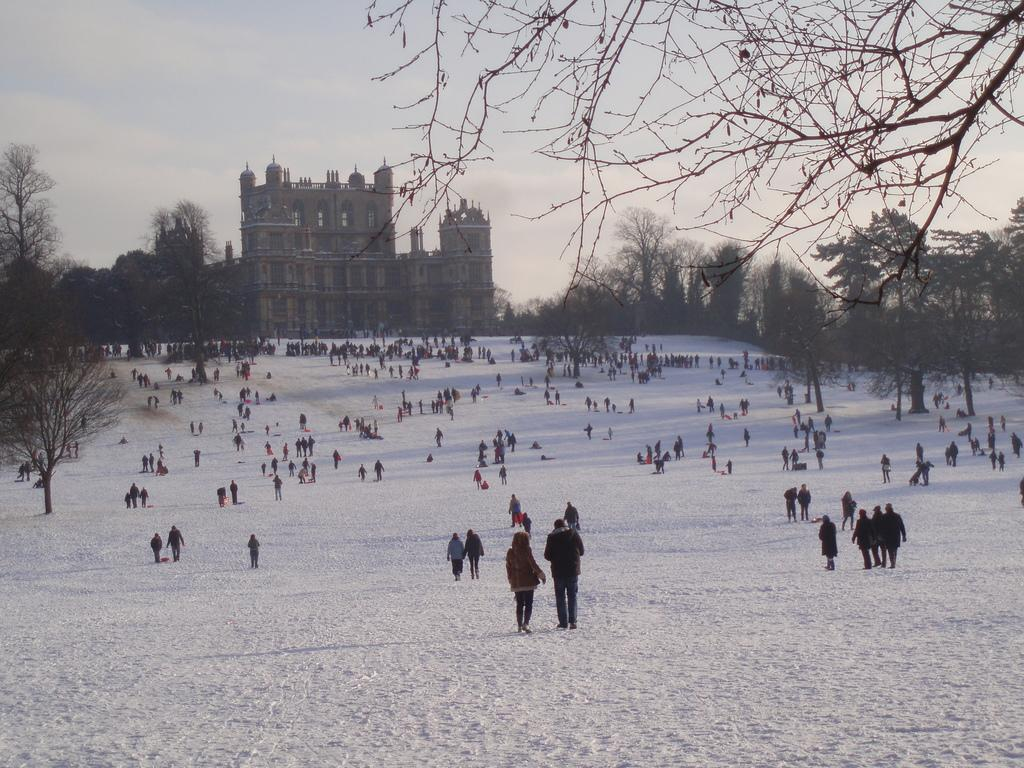What can be seen in the background of the image? The sky is visible in the background of the image. What type of structure is present in the image? There is a building in the image. What type of vegetation is present in the image? Trees are present in the image. What are the people in the image doing? People are standing, sitting, and walking in the image. What type of fuel is being used by the beetle in the image? There is no beetle present in the image, so it is not possible to determine what type of fuel it might be using. 